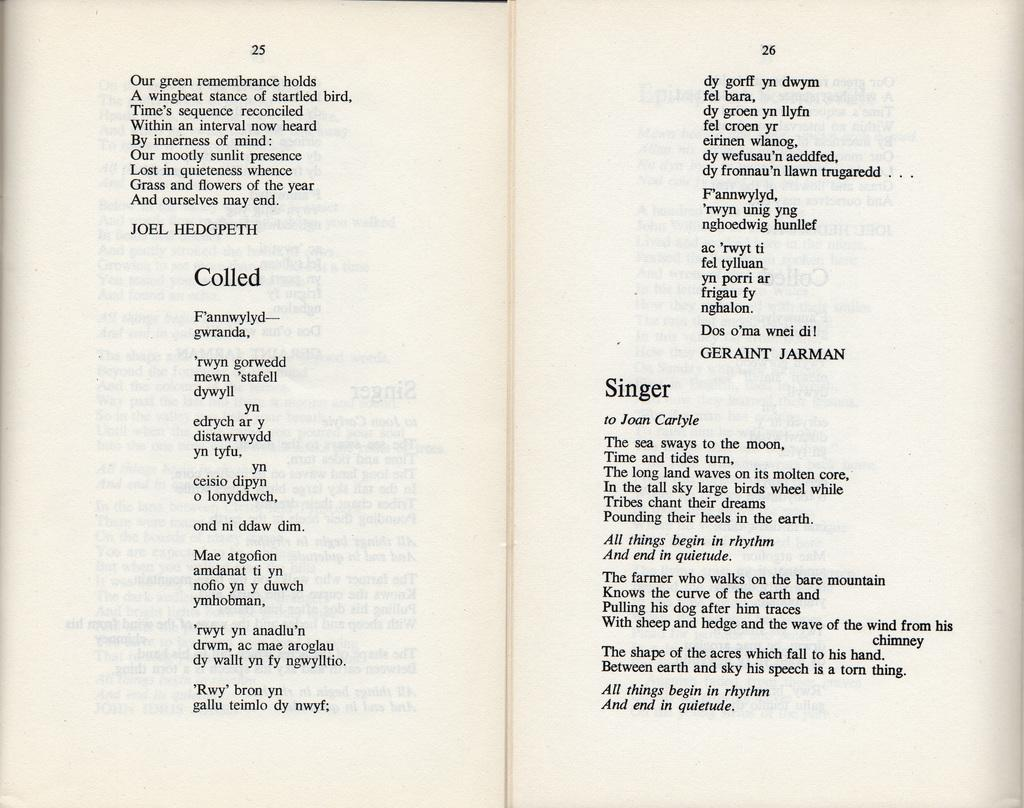<image>
Create a compact narrative representing the image presented. The Poems "Colled" by Joel Hedgpeth and the Poem "Singer" by Joan Carlyle are written. 